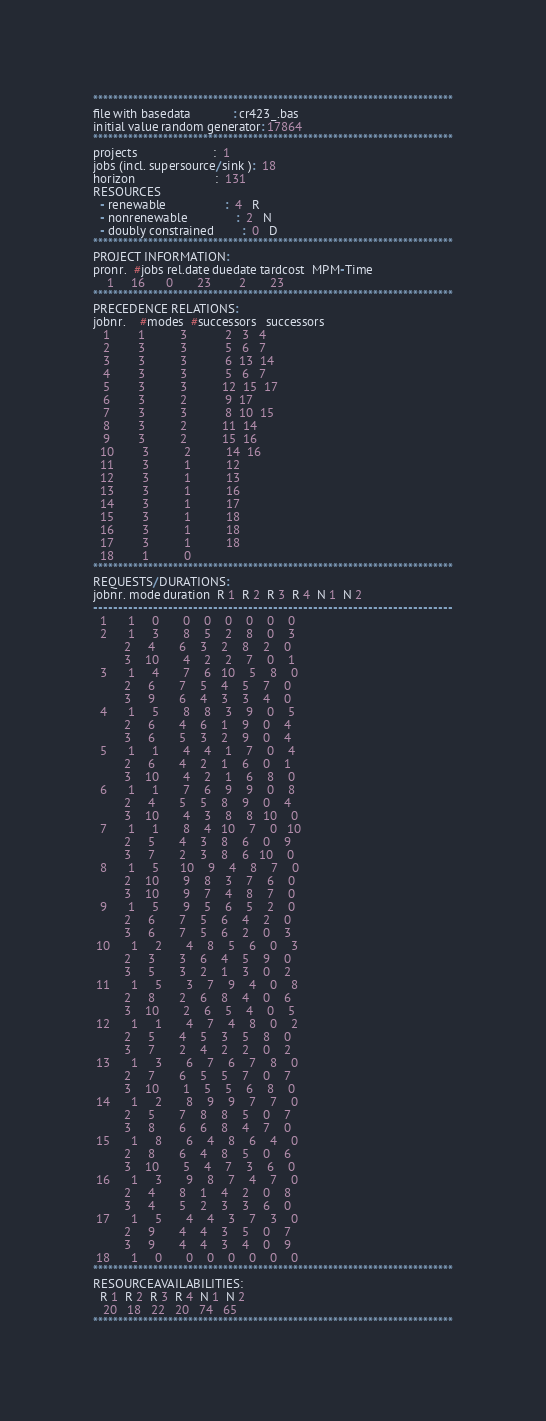<code> <loc_0><loc_0><loc_500><loc_500><_ObjectiveC_>************************************************************************
file with basedata            : cr423_.bas
initial value random generator: 17864
************************************************************************
projects                      :  1
jobs (incl. supersource/sink ):  18
horizon                       :  131
RESOURCES
  - renewable                 :  4   R
  - nonrenewable              :  2   N
  - doubly constrained        :  0   D
************************************************************************
PROJECT INFORMATION:
pronr.  #jobs rel.date duedate tardcost  MPM-Time
    1     16      0       23        2       23
************************************************************************
PRECEDENCE RELATIONS:
jobnr.    #modes  #successors   successors
   1        1          3           2   3   4
   2        3          3           5   6   7
   3        3          3           6  13  14
   4        3          3           5   6   7
   5        3          3          12  15  17
   6        3          2           9  17
   7        3          3           8  10  15
   8        3          2          11  14
   9        3          2          15  16
  10        3          2          14  16
  11        3          1          12
  12        3          1          13
  13        3          1          16
  14        3          1          17
  15        3          1          18
  16        3          1          18
  17        3          1          18
  18        1          0        
************************************************************************
REQUESTS/DURATIONS:
jobnr. mode duration  R 1  R 2  R 3  R 4  N 1  N 2
------------------------------------------------------------------------
  1      1     0       0    0    0    0    0    0
  2      1     3       8    5    2    8    0    3
         2     4       6    3    2    8    2    0
         3    10       4    2    2    7    0    1
  3      1     4       7    6   10    5    8    0
         2     6       7    5    4    5    7    0
         3     9       6    4    3    3    4    0
  4      1     5       8    8    3    9    0    5
         2     6       4    6    1    9    0    4
         3     6       5    3    2    9    0    4
  5      1     1       4    4    1    7    0    4
         2     6       4    2    1    6    0    1
         3    10       4    2    1    6    8    0
  6      1     1       7    6    9    9    0    8
         2     4       5    5    8    9    0    4
         3    10       4    3    8    8   10    0
  7      1     1       8    4   10    7    0   10
         2     5       4    3    8    6    0    9
         3     7       2    3    8    6   10    0
  8      1     5      10    9    4    8    7    0
         2    10       9    8    3    7    6    0
         3    10       9    7    4    8    7    0
  9      1     5       9    5    6    5    2    0
         2     6       7    5    6    4    2    0
         3     6       7    5    6    2    0    3
 10      1     2       4    8    5    6    0    3
         2     3       3    6    4    5    9    0
         3     5       3    2    1    3    0    2
 11      1     5       3    7    9    4    0    8
         2     8       2    6    8    4    0    6
         3    10       2    6    5    4    0    5
 12      1     1       4    7    4    8    0    2
         2     5       4    5    3    5    8    0
         3     7       2    4    2    2    0    2
 13      1     3       6    7    6    7    8    0
         2     7       6    5    5    7    0    7
         3    10       1    5    5    6    8    0
 14      1     2       8    9    9    7    7    0
         2     5       7    8    8    5    0    7
         3     8       6    6    8    4    7    0
 15      1     8       6    4    8    6    4    0
         2     8       6    4    8    5    0    6
         3    10       5    4    7    3    6    0
 16      1     3       9    8    7    4    7    0
         2     4       8    1    4    2    0    8
         3     4       5    2    3    3    6    0
 17      1     5       4    4    3    7    3    0
         2     9       4    4    3    5    0    7
         3     9       4    4    3    4    0    9
 18      1     0       0    0    0    0    0    0
************************************************************************
RESOURCEAVAILABILITIES:
  R 1  R 2  R 3  R 4  N 1  N 2
   20   18   22   20   74   65
************************************************************************
</code> 